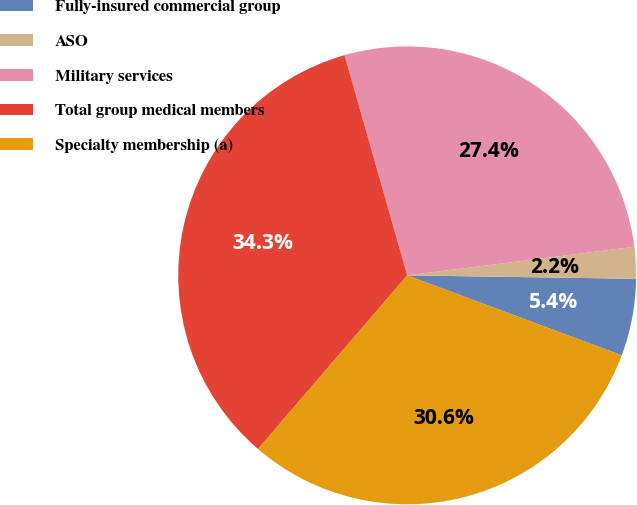Convert chart. <chart><loc_0><loc_0><loc_500><loc_500><pie_chart><fcel>Fully-insured commercial group<fcel>ASO<fcel>Military services<fcel>Total group medical members<fcel>Specialty membership (a)<nl><fcel>5.44%<fcel>2.23%<fcel>27.42%<fcel>34.29%<fcel>30.62%<nl></chart> 